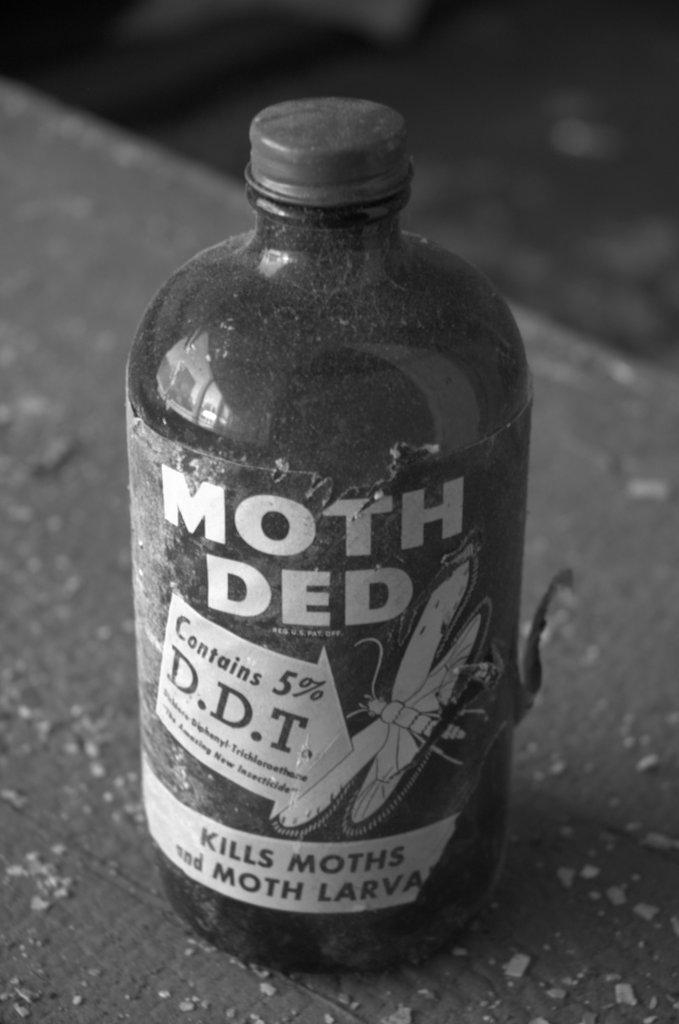Provide a one-sentence caption for the provided image. A dusty bottle of moth killer that contains 5% D.D.T. 